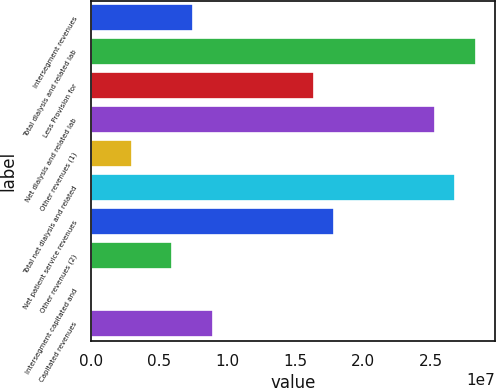<chart> <loc_0><loc_0><loc_500><loc_500><bar_chart><fcel>Intersegment revenues<fcel>Total dialysis and related lab<fcel>Less Provision for<fcel>Net dialysis and related lab<fcel>Other revenues (1)<fcel>Total net dialysis and related<fcel>Net patient service revenues<fcel>Other revenues (2)<fcel>Intersegment capitated and<fcel>Capitated revenues<nl><fcel>7.4366e+06<fcel>2.82585e+07<fcel>1.63603e+07<fcel>2.52839e+07<fcel>2.97477e+06<fcel>2.67712e+07<fcel>1.78475e+07<fcel>5.94932e+06<fcel>215<fcel>8.92387e+06<nl></chart> 